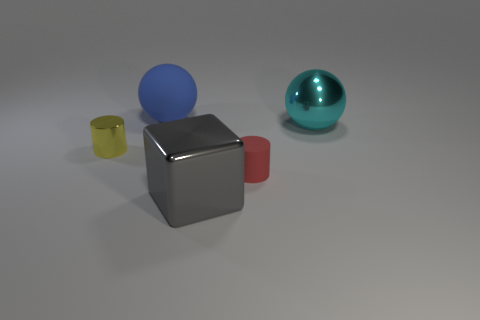Add 4 cyan things. How many objects exist? 9 Subtract all cyan balls. How many balls are left? 1 Subtract 1 blocks. How many blocks are left? 0 Subtract all cyan cubes. Subtract all green cylinders. How many cubes are left? 1 Subtract all purple cubes. How many blue spheres are left? 1 Subtract all blue metal cylinders. Subtract all cyan things. How many objects are left? 4 Add 4 gray objects. How many gray objects are left? 5 Add 4 small purple objects. How many small purple objects exist? 4 Subtract 1 yellow cylinders. How many objects are left? 4 Subtract all spheres. How many objects are left? 3 